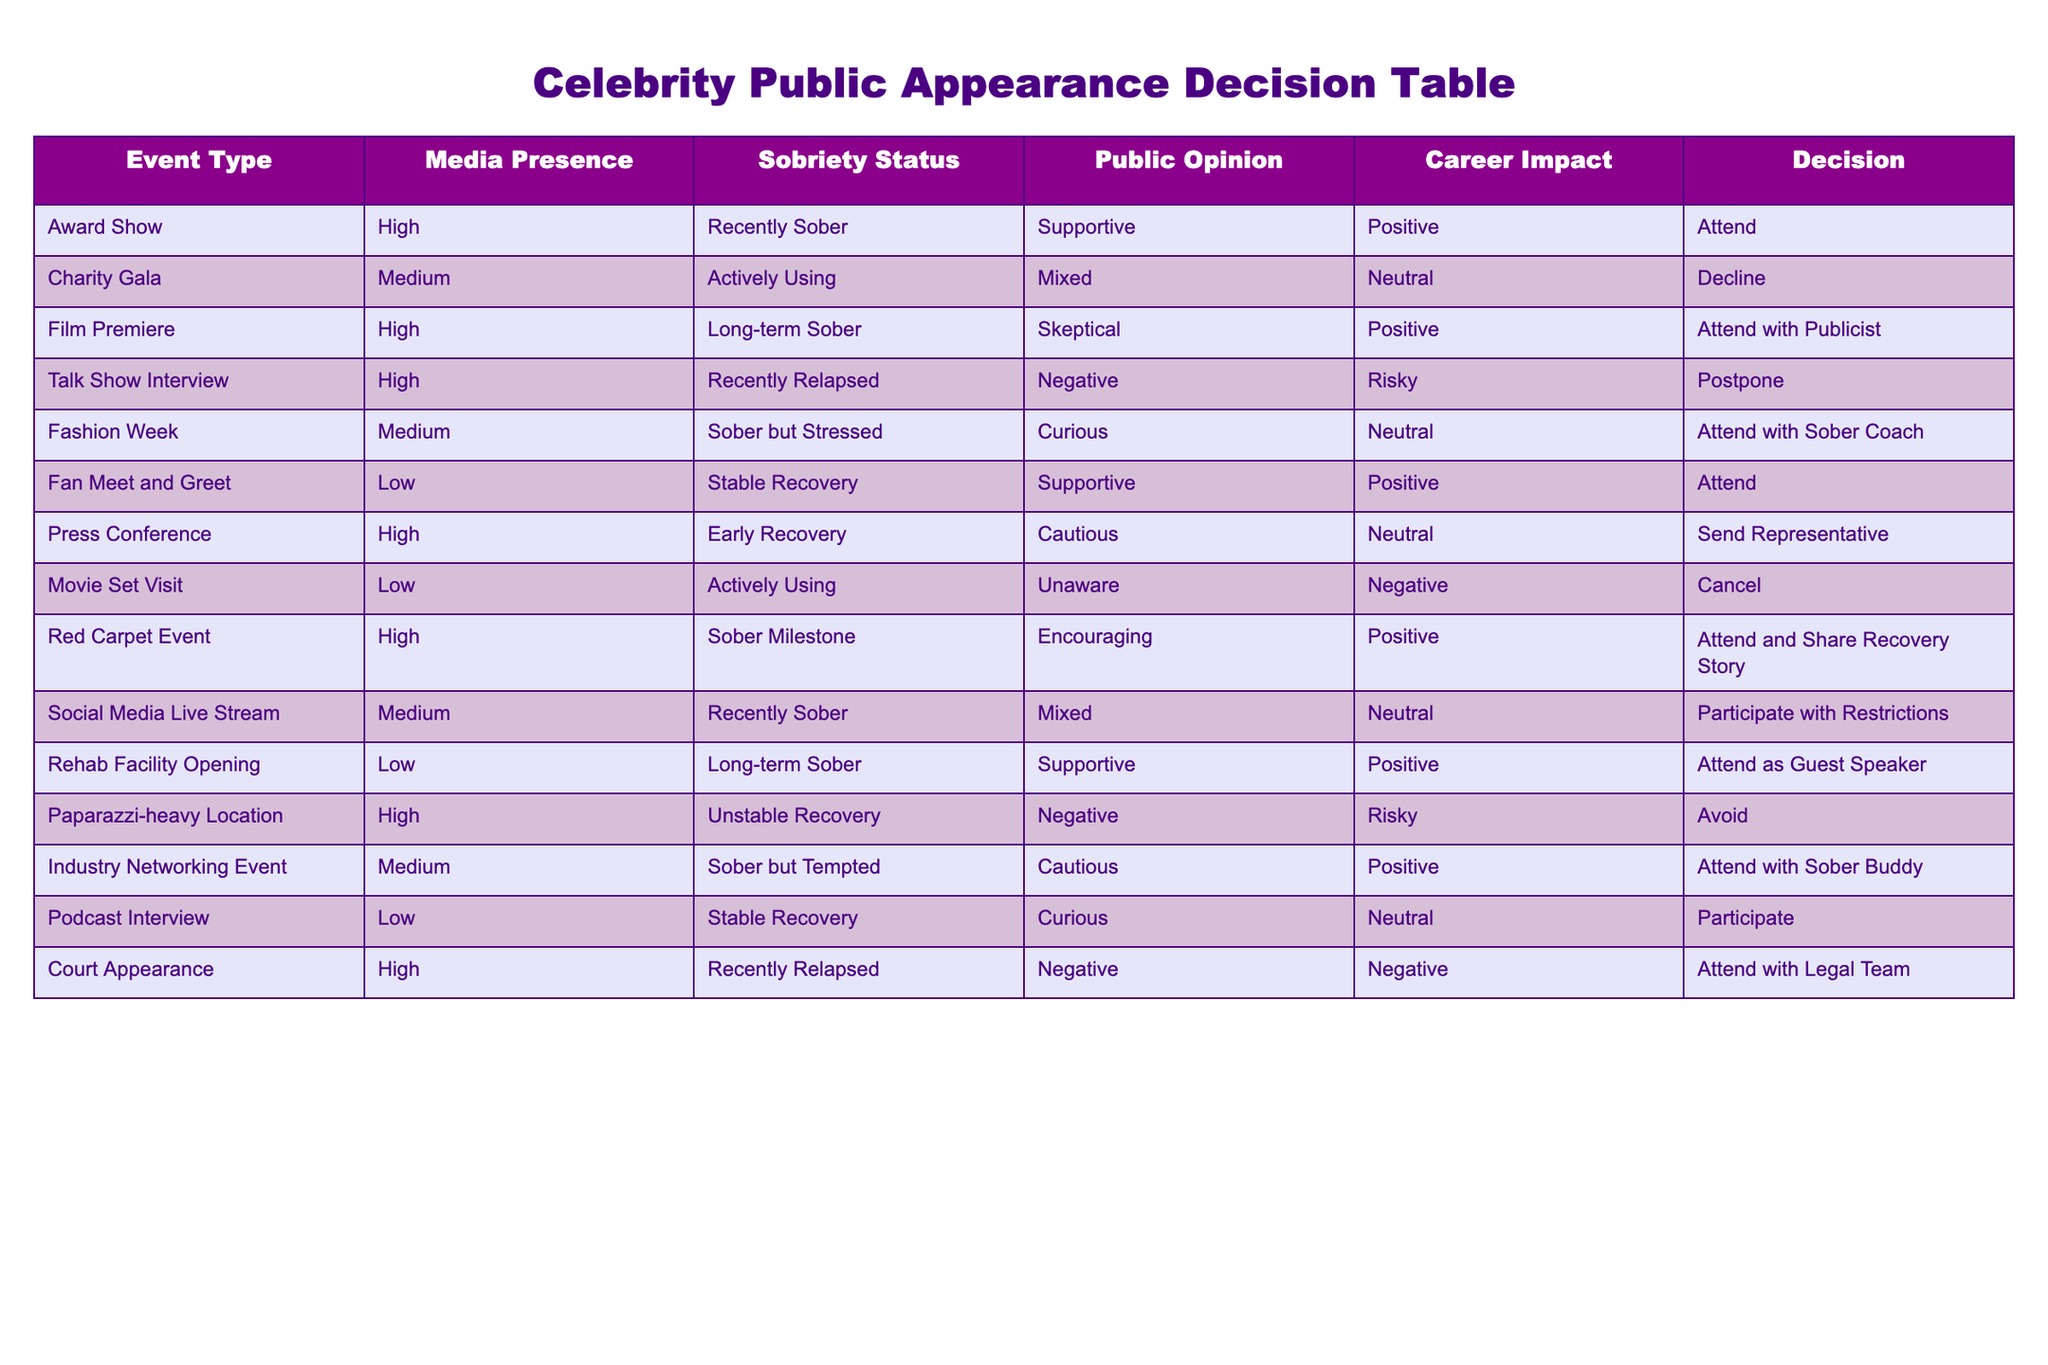What is the decision for attending the Award Show? The table indicates that for the Award Show, the decision is to "Attend" since the media presence is high, the sobriety status is recently sober, and the public opinion is supportive.
Answer: Attend How many events have a negative public opinion? From the table, the events with a negative public opinion are the Talk Show Interview, Movie Set Visit, Court Appearance, and Paparazzi-heavy Location. This totals 4 events.
Answer: 4 Is it true that attending a charity gala is recommended when actively using? According to the table, the decision for the Charity Gala when actively using is to "Decline," indicating that it is not recommended.
Answer: No What types of events should one attend when stable in recovery? The table shows that when stable in recovery, one should consider attending a Fan Meet and Greet and a Podcast Interview, as both are advisable in this sobriety status.
Answer: Fan Meet and Greet, Podcast Interview What is the difference in career impact between attending a Fashion Week event and a Talk Show Interview when recently relapsed? The career impact for attending Fashion Week is neutral while for a Talk Show Interview is risky. The difference indicates that Fashion Week poses a lesser risk to career impact than the Talk Show Interview.
Answer: Fashion Week is neutral, Talk Show Interview is risky For events with medium media presence, how many are associated with a neutral career impact? The events with medium media presence that have a neutral career impact are the Charity Gala and Fashion Week, giving a total of 2 events.
Answer: 2 Is it advisable to attend the Press Conference for someone in early recovery? The decision for attending the Press Conference when in early recovery is to "Send Representative," which suggests that it is not advisable for the individual to attend personally.
Answer: No Which event has the most supportive public opinion and what is the decision? The event with the most supportive public opinion is the Fan Meet and Greet, with the decision being to "Attend."
Answer: Fan Meet and Greet, Attend 